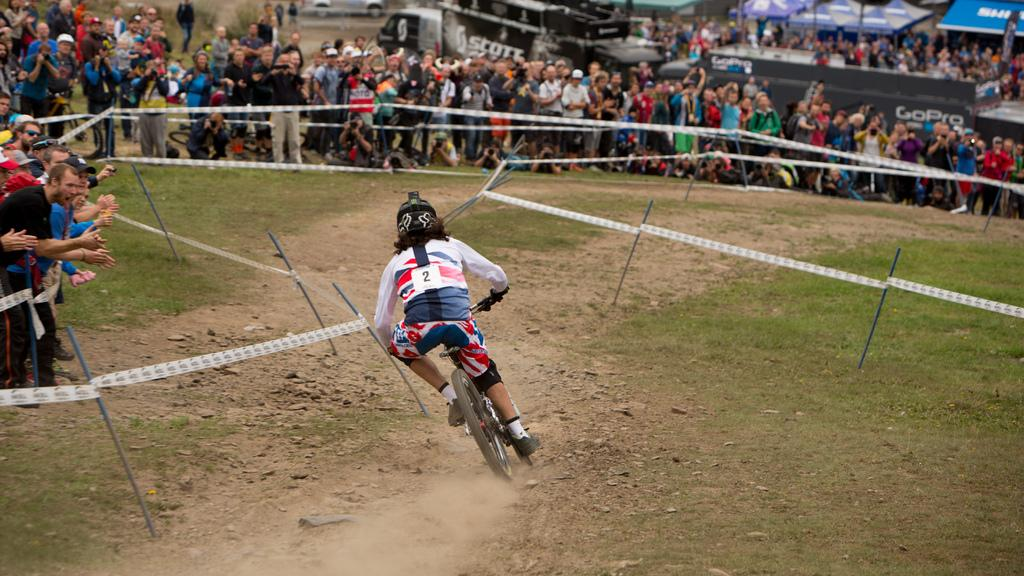<image>
Offer a succinct explanation of the picture presented. A bicyclist with no 2 on the back is riding through the winding track. 